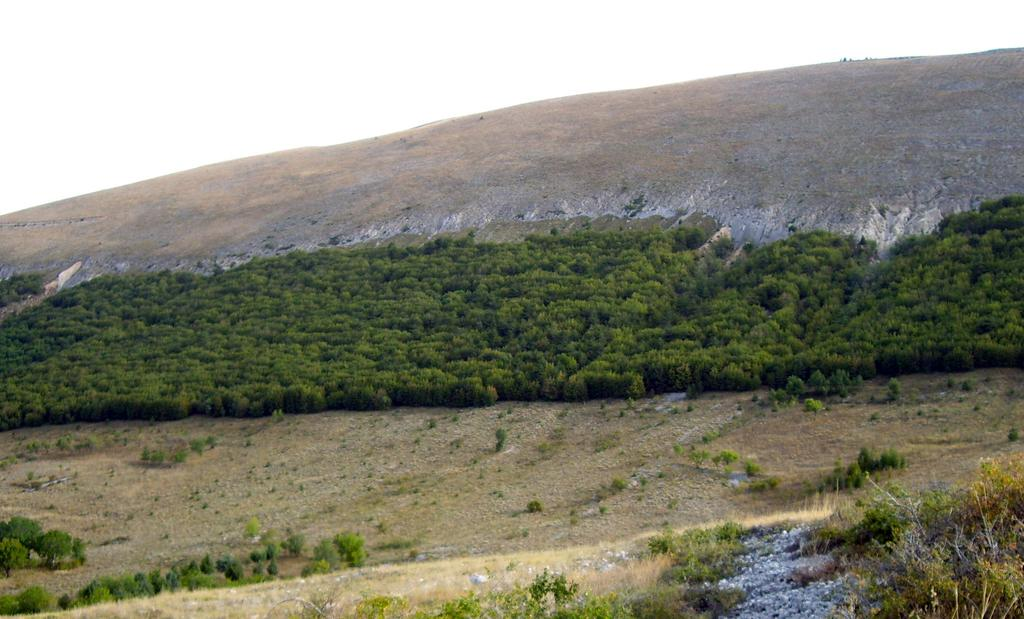What type of vegetation can be seen on the grassland in the image? There are trees on the grassland in the image. What geographical feature is visible in the background of the image? There is a hill visible in the background of the image. What is visible at the top of the image? The sky is visible at the top of the image. What type of natural formation can be seen on the land in the right bottom of the image? There are rocks on the land in the right bottom of the image. Where is the mailbox located in the image? There is no mailbox present in the image. What type of twig can be seen on the hill in the image? There is no twig visible on the hill in the image. 